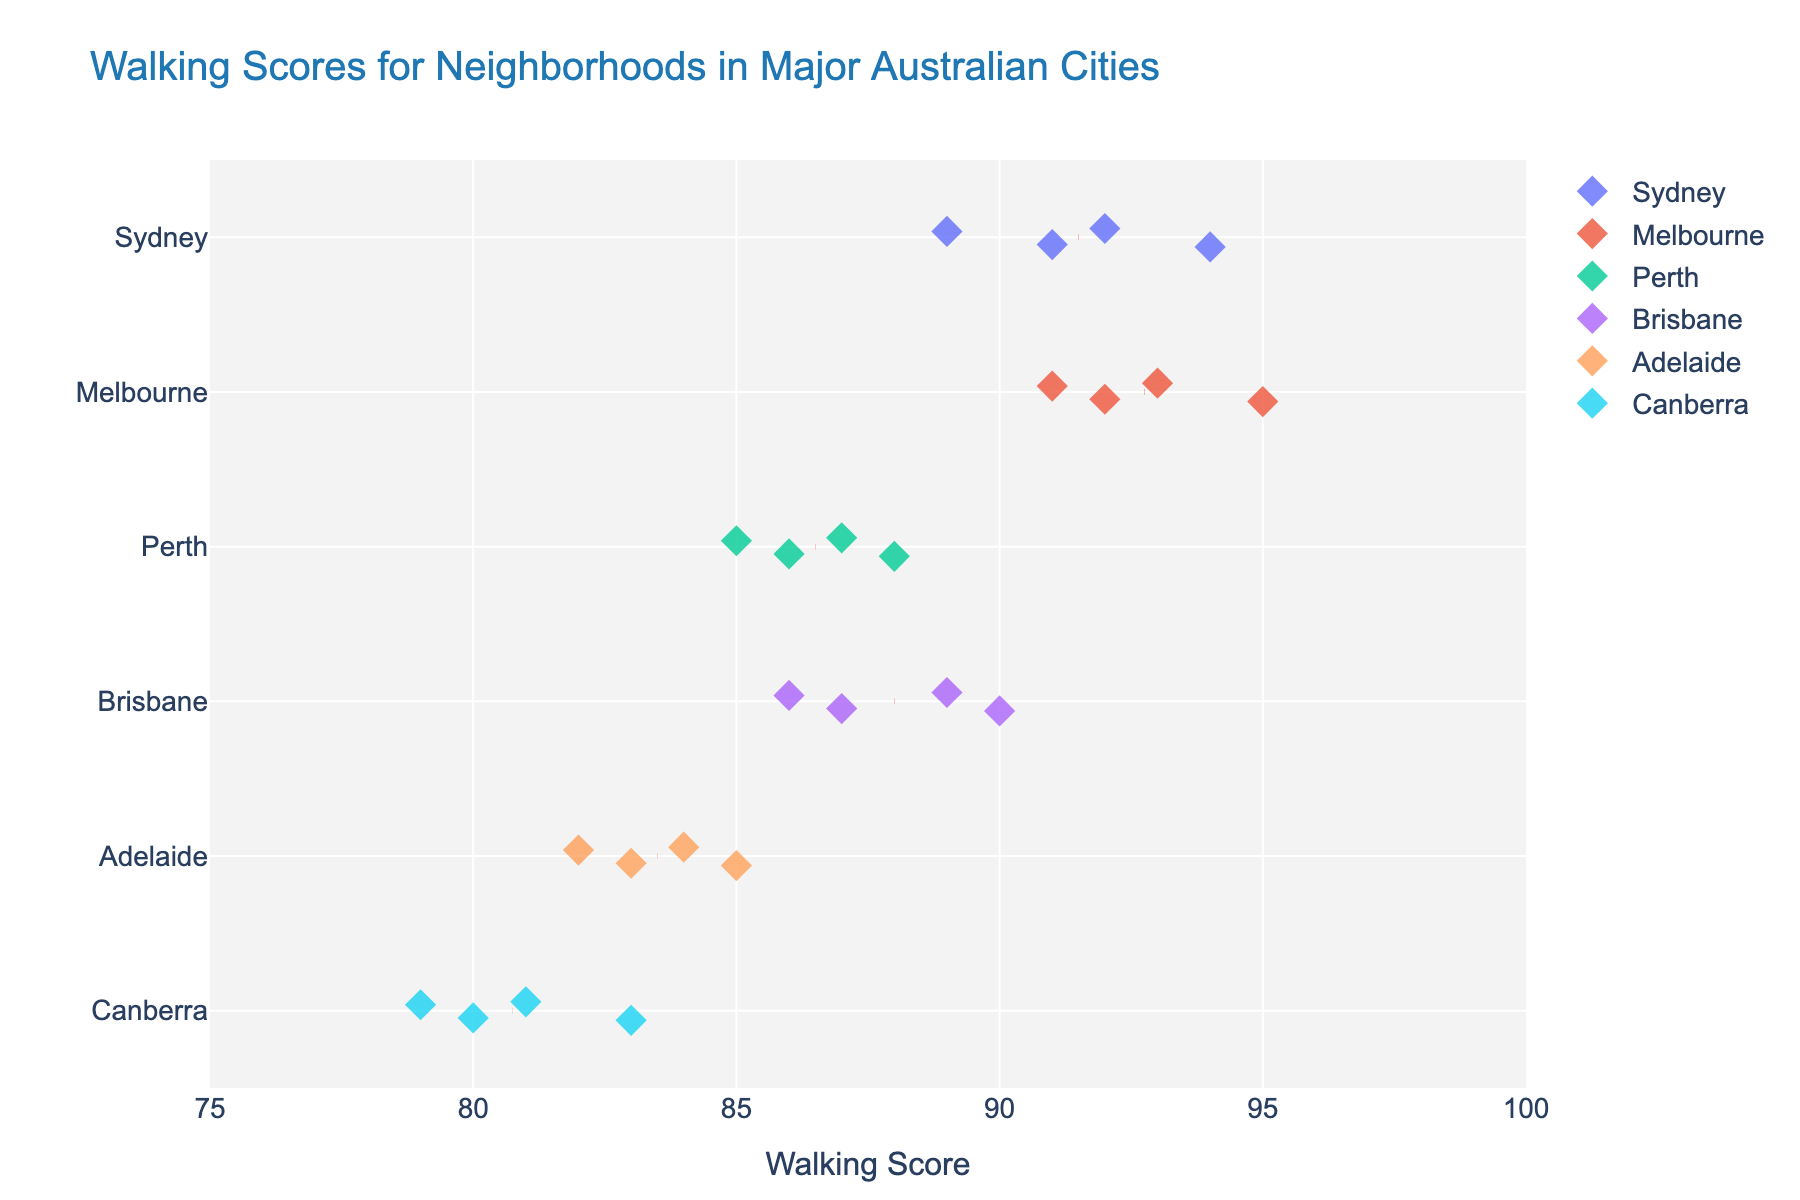How many neighborhoods are represented in the plot? Count all the data points listed for neighborhoods in the figure.
Answer: 24 What is the title of the plot? Read the title displayed at the top of the plot.
Answer: "Walking Scores for Neighborhoods in Major Australian Cities" What is the range of walking scores presented in the plot? Observe the x-axis labels to determine the minimum and maximum values. The range of Walking Scores is 75 to 100 as per the custom x-axis range defined.
Answer: 75 to 100 Which city has the neighborhood with the highest walking score? Look at the data points and identify the neighborhood with the highest score, then find the respective city. Melbourne CBD has the highest walking score of 95.
Answer: Melbourne Which city has the lowest average walking score? Observe the red dashed lines representing the average walking scores for each city and identify the lowest one. Canberra has the lowest average walking score with its red dashed line appearing lowest on the score axis.
Answer: Canberra What are the walking scores of the neighborhoods in Sydney? Identify the data points under Sydney and list out their values: Surry Hills (92), Darlinghurst (94), Newtown (91), Glebe (89).
Answer: 92, 94, 91, 89 How does the walking score of Fitzroy (Melbourne) compare to Northbridge (Perth)? Locate the data points for Fitzroy (93) in Melbourne and Northbridge (88) in Perth and compare their values. Fitzroy has a higher walking score.
Answer: Fitzroy is higher Which city has the largest spread (range) in walking scores? Look at the spread of data points for each city and identify the city with the largest difference between the highest and lowest scores. Sydney has a spread from 89 to 94, Perth has a spread from 85 to 88, Melbourne has from 91 to 95, Brisbane has a spread from 86 to 90, Adelaide has from 82 to 85, and Canberra has the spread from 79 to 83. Melbourne has the largest range (4).
Answer: Melbourne Which neighborhood in Canberra has the lowest walking score? Find the data points related to Canberra and determine the one with the lowest score. Dickson has the lowest walking score of 79 in Canberra.
Answer: Dickson What is the average walking score of neighborhoods in Brisbane? Calculate the average of walking scores for Brisbane neighborhoods: (90 + 89 + 87 + 86) / 4 = 88.
Answer: 88 